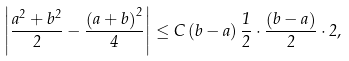Convert formula to latex. <formula><loc_0><loc_0><loc_500><loc_500>\left | \frac { a ^ { 2 } + b ^ { 2 } } { 2 } - \frac { \left ( a + b \right ) ^ { 2 } } { 4 } \right | \leq C \left ( b - a \right ) \frac { 1 } { 2 } \cdot \frac { \left ( b - a \right ) } { 2 } \cdot 2 ,</formula> 